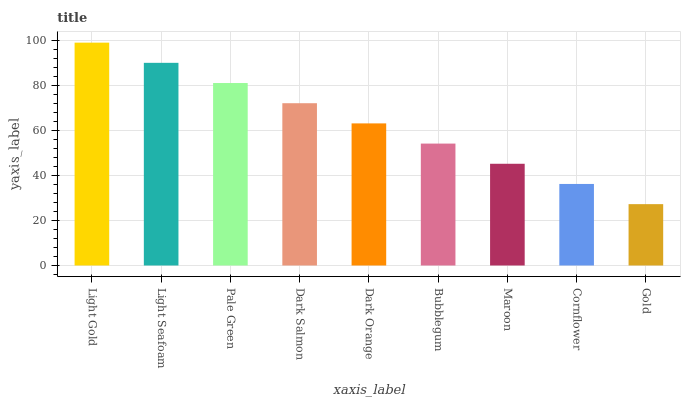Is Gold the minimum?
Answer yes or no. Yes. Is Light Gold the maximum?
Answer yes or no. Yes. Is Light Seafoam the minimum?
Answer yes or no. No. Is Light Seafoam the maximum?
Answer yes or no. No. Is Light Gold greater than Light Seafoam?
Answer yes or no. Yes. Is Light Seafoam less than Light Gold?
Answer yes or no. Yes. Is Light Seafoam greater than Light Gold?
Answer yes or no. No. Is Light Gold less than Light Seafoam?
Answer yes or no. No. Is Dark Orange the high median?
Answer yes or no. Yes. Is Dark Orange the low median?
Answer yes or no. Yes. Is Pale Green the high median?
Answer yes or no. No. Is Gold the low median?
Answer yes or no. No. 